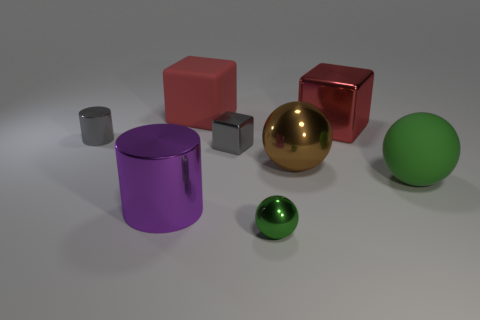Add 1 big brown things. How many objects exist? 9 Subtract all cubes. How many objects are left? 5 Add 2 gray metallic cylinders. How many gray metallic cylinders exist? 3 Subtract 1 gray cylinders. How many objects are left? 7 Subtract all large purple objects. Subtract all red rubber objects. How many objects are left? 6 Add 6 small metallic balls. How many small metallic balls are left? 7 